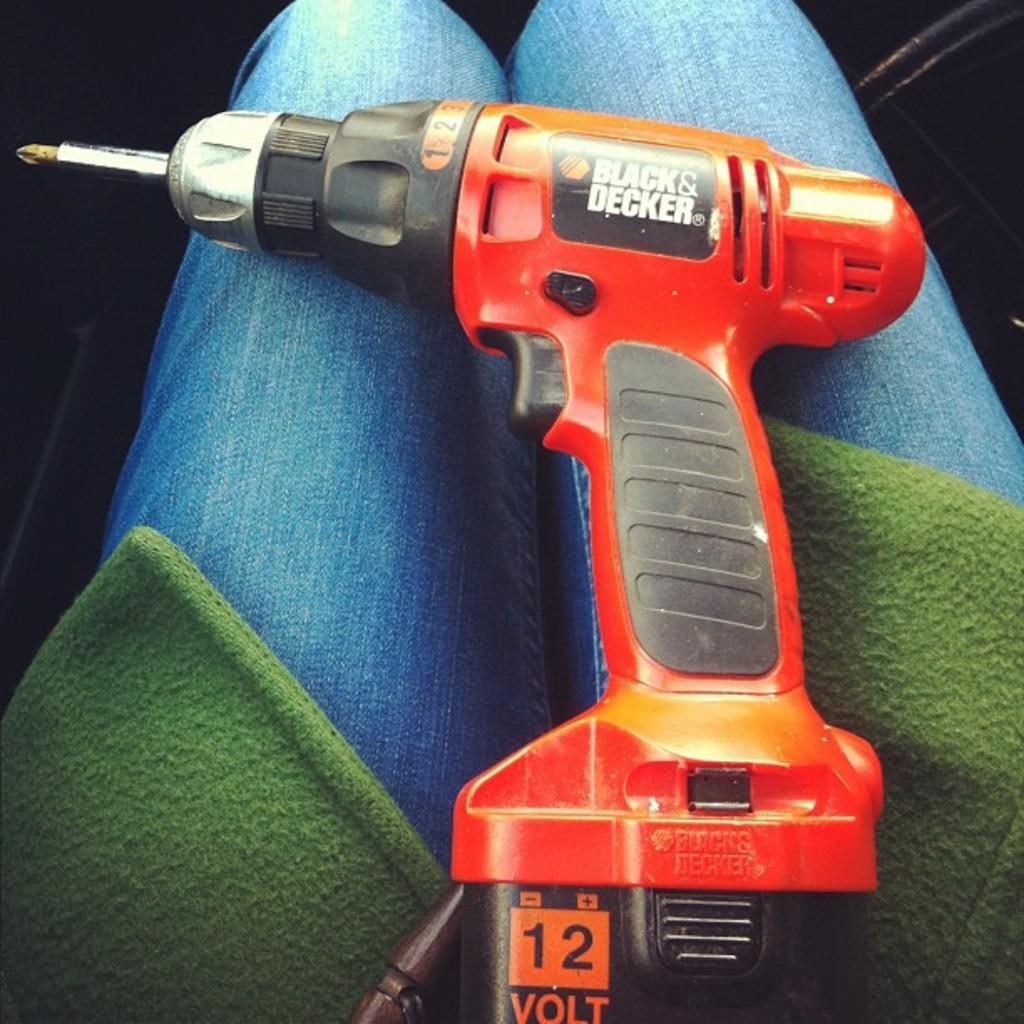Describe this image in one or two sentences. In this image I can see an orange colour drill machine, green colour clothes, blue jeans and on this machine I can see something is written. I can also see black colour in background. 